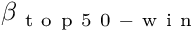<formula> <loc_0><loc_0><loc_500><loc_500>\beta _ { t o p 5 0 - w i n }</formula> 